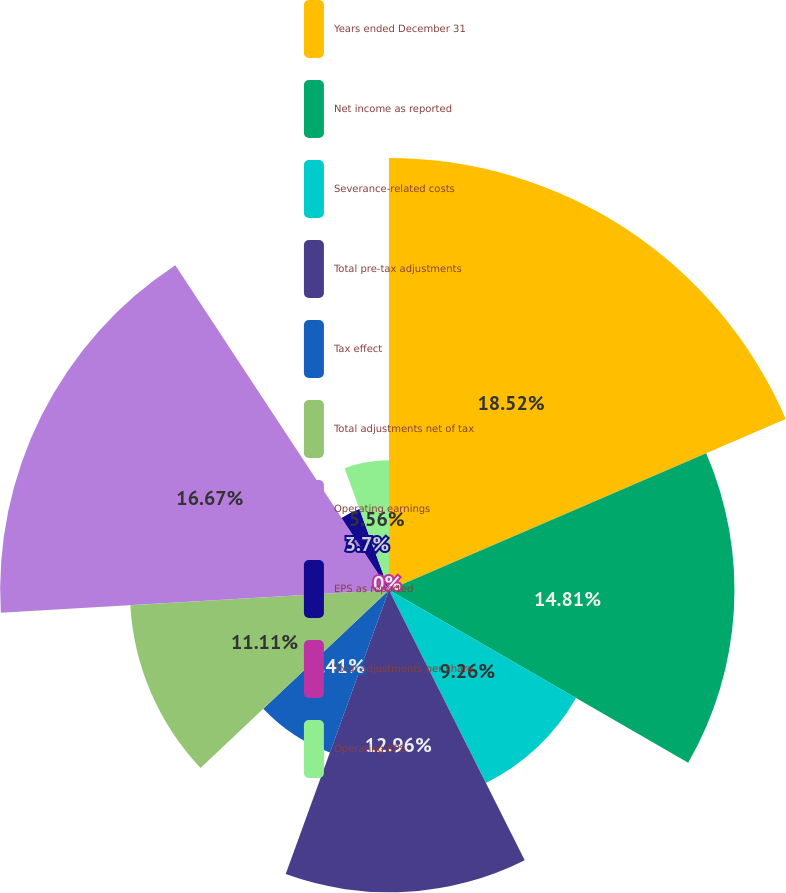<chart> <loc_0><loc_0><loc_500><loc_500><pie_chart><fcel>Years ended December 31<fcel>Net income as reported<fcel>Severance-related costs<fcel>Total pre-tax adjustments<fcel>Tax effect<fcel>Total adjustments net of tax<fcel>Operating earnings<fcel>EPS as reported<fcel>Total adjustments per share<fcel>Operating EPS<nl><fcel>18.52%<fcel>14.81%<fcel>9.26%<fcel>12.96%<fcel>7.41%<fcel>11.11%<fcel>16.67%<fcel>3.7%<fcel>0.0%<fcel>5.56%<nl></chart> 